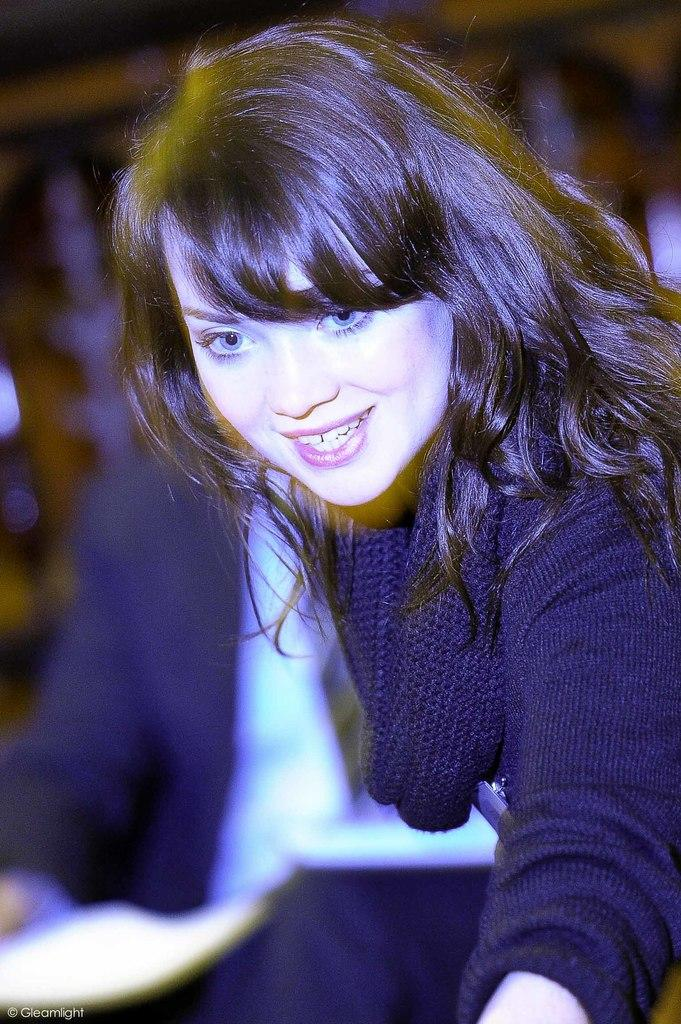Who is present in the image? There is a woman in the image. What is the woman doing in the image? The woman is smiling in the image. Who else is present in the image? There is a man seated in the image. What is the woman wearing in the image? The woman is wearing a black dress in the image. What type of whip can be seen in the woman's hand in the image? There is no whip present in the image. What does the bird taste like in the image? There is no bird present in the image, so it cannot be tasted. 